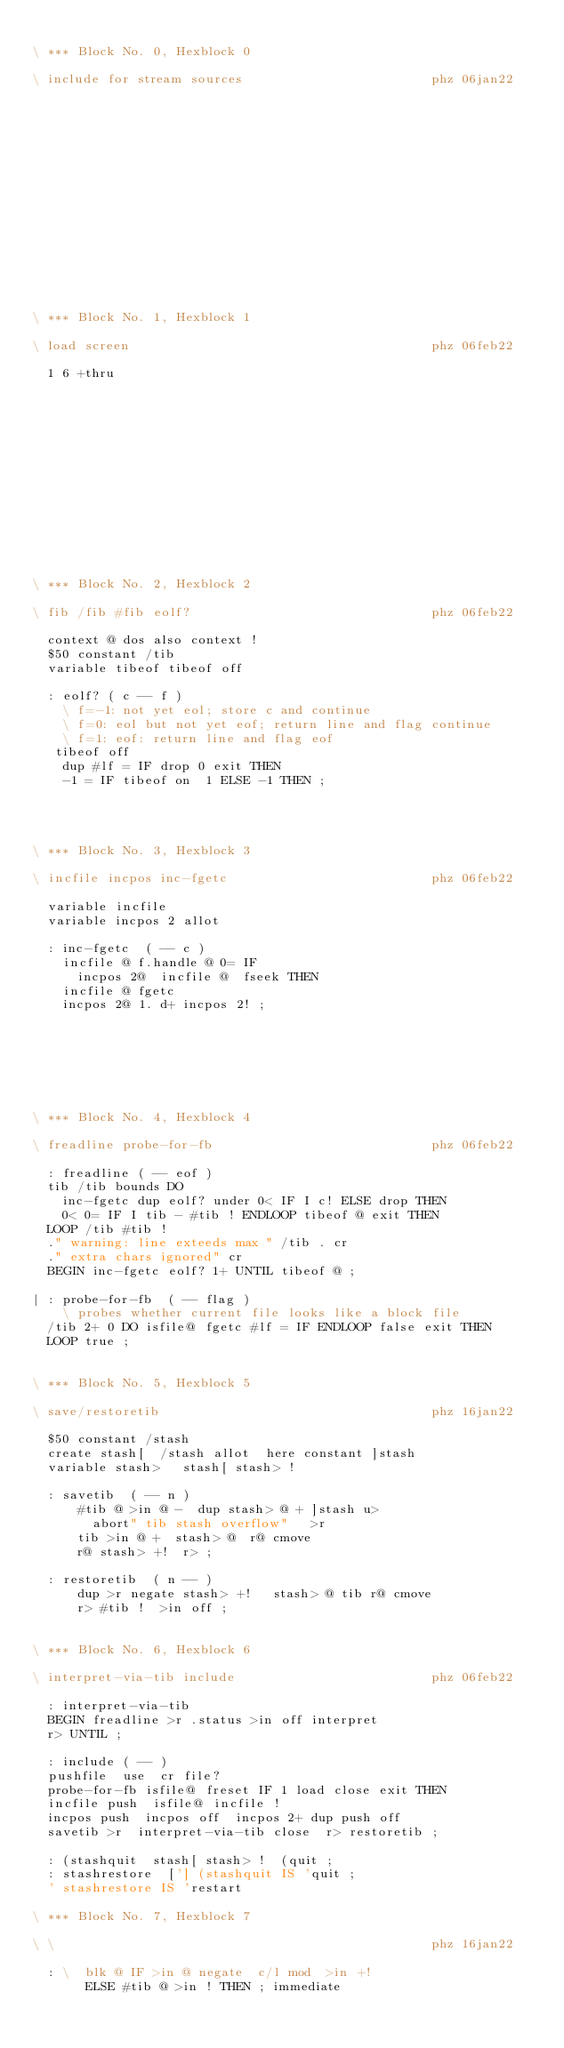Convert code to text. <code><loc_0><loc_0><loc_500><loc_500><_Forth_>
\ *** Block No. 0, Hexblock 0

\ include for stream sources                         phz 06jan22
















\ *** Block No. 1, Hexblock 1

\ load screen                                        phz 06feb22

  1 6 +thru














\ *** Block No. 2, Hexblock 2

\ fib /fib #fib eolf?                                phz 06feb22

  context @ dos also context !
  $50 constant /tib
  variable tibeof tibeof off

  : eolf? ( c -- f )
    \ f=-1: not yet eol; store c and continue
    \ f=0: eol but not yet eof; return line and flag continue
    \ f=1: eof: return line and flag eof
   tibeof off
    dup #lf = IF drop 0 exit THEN
    -1 = IF tibeof on  1 ELSE -1 THEN ;




\ *** Block No. 3, Hexblock 3

\ incfile incpos inc-fgetc                           phz 06feb22

  variable incfile
  variable incpos 2 allot

  : inc-fgetc  ( -- c )
    incfile @ f.handle @ 0= IF
      incpos 2@  incfile @  fseek THEN
    incfile @ fgetc
    incpos 2@ 1. d+ incpos 2! ;







\ *** Block No. 4, Hexblock 4

\ freadline probe-for-fb                             phz 06feb22

  : freadline ( -- eof )
  tib /tib bounds DO
    inc-fgetc dup eolf? under 0< IF I c! ELSE drop THEN
    0< 0= IF I tib - #tib ! ENDLOOP tibeof @ exit THEN
  LOOP /tib #tib !
  ." warning: line exteeds max " /tib . cr
  ." extra chars ignored" cr
  BEGIN inc-fgetc eolf? 1+ UNTIL tibeof @ ;

| : probe-for-fb  ( -- flag )
    \ probes whether current file looks like a block file
  /tib 2+ 0 DO isfile@ fgetc #lf = IF ENDLOOP false exit THEN
  LOOP true ;


\ *** Block No. 5, Hexblock 5

\ save/restoretib                                    phz 16jan22

  $50 constant /stash
  create stash[  /stash allot  here constant ]stash
  variable stash>   stash[ stash> !

  : savetib  ( -- n )
      #tib @ >in @ -  dup stash> @ + ]stash u>
        abort" tib stash overflow"   >r
      tib >in @ +  stash> @  r@ cmove
      r@ stash> +!  r> ;

  : restoretib  ( n -- )
      dup >r negate stash> +!   stash> @ tib r@ cmove
      r> #tib !  >in off ;


\ *** Block No. 6, Hexblock 6

\ interpret-via-tib include                          phz 06feb22

  : interpret-via-tib
  BEGIN freadline >r .status >in off interpret
  r> UNTIL ;

  : include ( -- )
  pushfile  use  cr file?
  probe-for-fb isfile@ freset IF 1 load close exit THEN
  incfile push  isfile@ incfile !
  incpos push  incpos off  incpos 2+ dup push off
  savetib >r  interpret-via-tib close  r> restoretib ;

  : (stashquit  stash[ stash> !  (quit ;
  : stashrestore  ['] (stashquit IS 'quit ;
  ' stashrestore IS 'restart

\ *** Block No. 7, Hexblock 7

\ \                                                  phz 16jan22

  : \  blk @ IF >in @ negate  c/l mod  >in +!
       ELSE #tib @ >in ! THEN ; immediate












</code> 